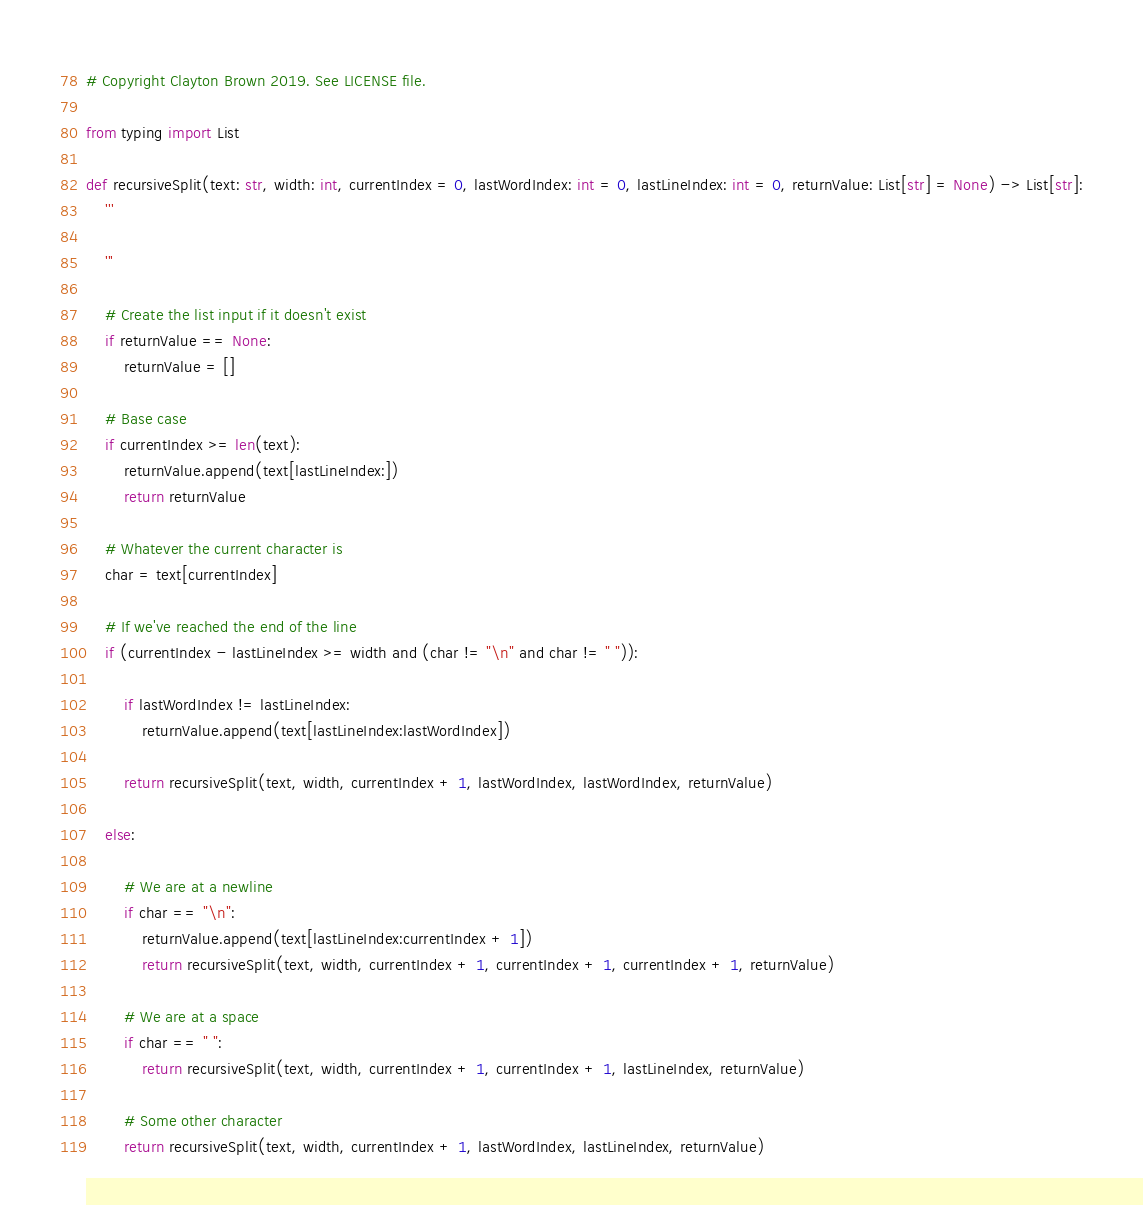Convert code to text. <code><loc_0><loc_0><loc_500><loc_500><_Python_># Copyright Clayton Brown 2019. See LICENSE file.

from typing import List

def recursiveSplit(text: str, width: int, currentIndex = 0, lastWordIndex: int = 0, lastLineIndex: int = 0, returnValue: List[str] = None) -> List[str]:
    '''

    '''

    # Create the list input if it doesn't exist
    if returnValue == None:
        returnValue = []

    # Base case
    if currentIndex >= len(text):
        returnValue.append(text[lastLineIndex:])
        return returnValue
    
    # Whatever the current character is
    char = text[currentIndex]

    # If we've reached the end of the line
    if (currentIndex - lastLineIndex >= width and (char != "\n" and char != " ")):
        
        if lastWordIndex != lastLineIndex:
            returnValue.append(text[lastLineIndex:lastWordIndex])

        return recursiveSplit(text, width, currentIndex + 1, lastWordIndex, lastWordIndex, returnValue)
    
    else:

        # We are at a newline
        if char == "\n":
            returnValue.append(text[lastLineIndex:currentIndex + 1])
            return recursiveSplit(text, width, currentIndex + 1, currentIndex + 1, currentIndex + 1, returnValue)

        # We are at a space
        if char == " ":
            return recursiveSplit(text, width, currentIndex + 1, currentIndex + 1, lastLineIndex, returnValue)

        # Some other character
        return recursiveSplit(text, width, currentIndex + 1, lastWordIndex, lastLineIndex, returnValue)</code> 